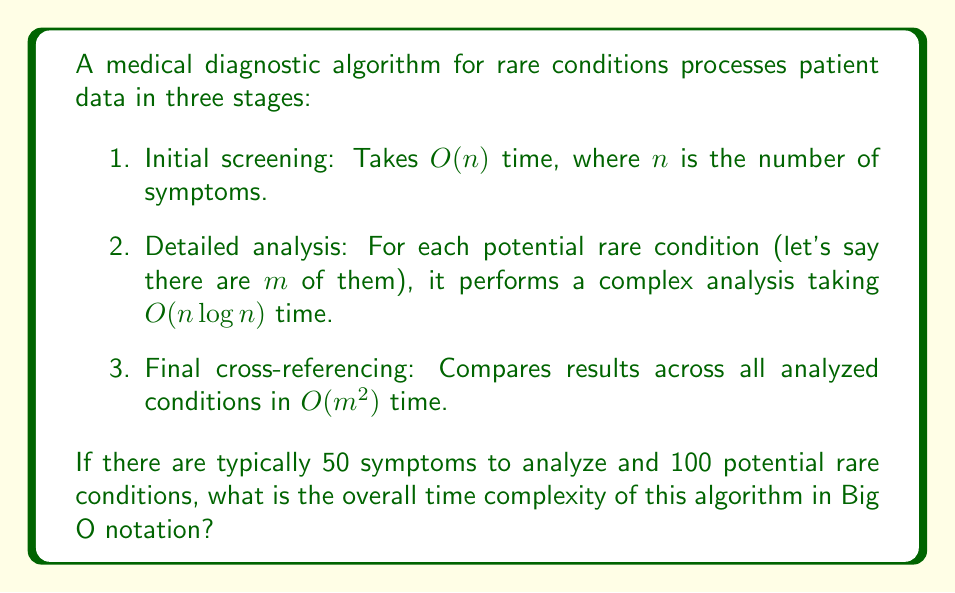Can you solve this math problem? Let's break down the algorithm's time complexity step by step:

1. Initial screening: $O(n)$ where $n = 50$

2. Detailed analysis: 
   This step is performed $m$ times, where $m = 100$
   Each analysis takes $O(n \log n)$ time
   Total time for this step: $O(m \cdot n \log n)$

3. Final cross-referencing: $O(m^2)$ where $m = 100$

To find the overall time complexity, we need to sum these components:

$$O(n) + O(m \cdot n \log n) + O(m^2)$$

Substituting the given values:

$$O(50) + O(100 \cdot 50 \log 50) + O(100^2)$$

Simplifying:

$$O(1) + O(5000 \log 50) + O(10000)$$

The dominant term here is $O(5000 \log 50)$, which simplifies to $O(n \log n)$ in terms of $n$.

However, since $m$ is also a variable in our original problem, we should express the final complexity in terms of both $n$ and $m$:

$$O(m \cdot n \log n)$$

This term dominates both $O(n)$ and $O(m^2)$ for the given values and for most practical scenarios where $n$ and $m$ are large.
Answer: $O(m \cdot n \log n)$ 